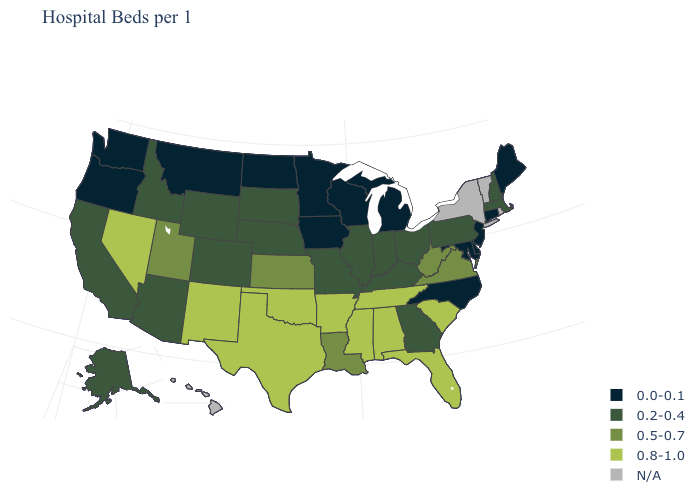Name the states that have a value in the range 0.2-0.4?
Keep it brief. Alaska, Arizona, California, Colorado, Georgia, Idaho, Illinois, Indiana, Kentucky, Massachusetts, Missouri, Nebraska, New Hampshire, Ohio, Pennsylvania, South Dakota, Wyoming. What is the value of Florida?
Be succinct. 0.8-1.0. Among the states that border Minnesota , which have the highest value?
Give a very brief answer. South Dakota. What is the lowest value in the MidWest?
Short answer required. 0.0-0.1. Name the states that have a value in the range 0.0-0.1?
Quick response, please. Connecticut, Delaware, Iowa, Maine, Maryland, Michigan, Minnesota, Montana, New Jersey, North Carolina, North Dakota, Oregon, Washington, Wisconsin. What is the lowest value in the Northeast?
Write a very short answer. 0.0-0.1. Name the states that have a value in the range 0.8-1.0?
Short answer required. Alabama, Arkansas, Florida, Mississippi, Nevada, New Mexico, Oklahoma, South Carolina, Tennessee, Texas. Among the states that border Maine , which have the highest value?
Short answer required. New Hampshire. What is the value of Washington?
Be succinct. 0.0-0.1. Name the states that have a value in the range 0.5-0.7?
Keep it brief. Kansas, Louisiana, Utah, Virginia, West Virginia. What is the value of New Hampshire?
Quick response, please. 0.2-0.4. What is the value of Montana?
Keep it brief. 0.0-0.1. Is the legend a continuous bar?
Concise answer only. No. 